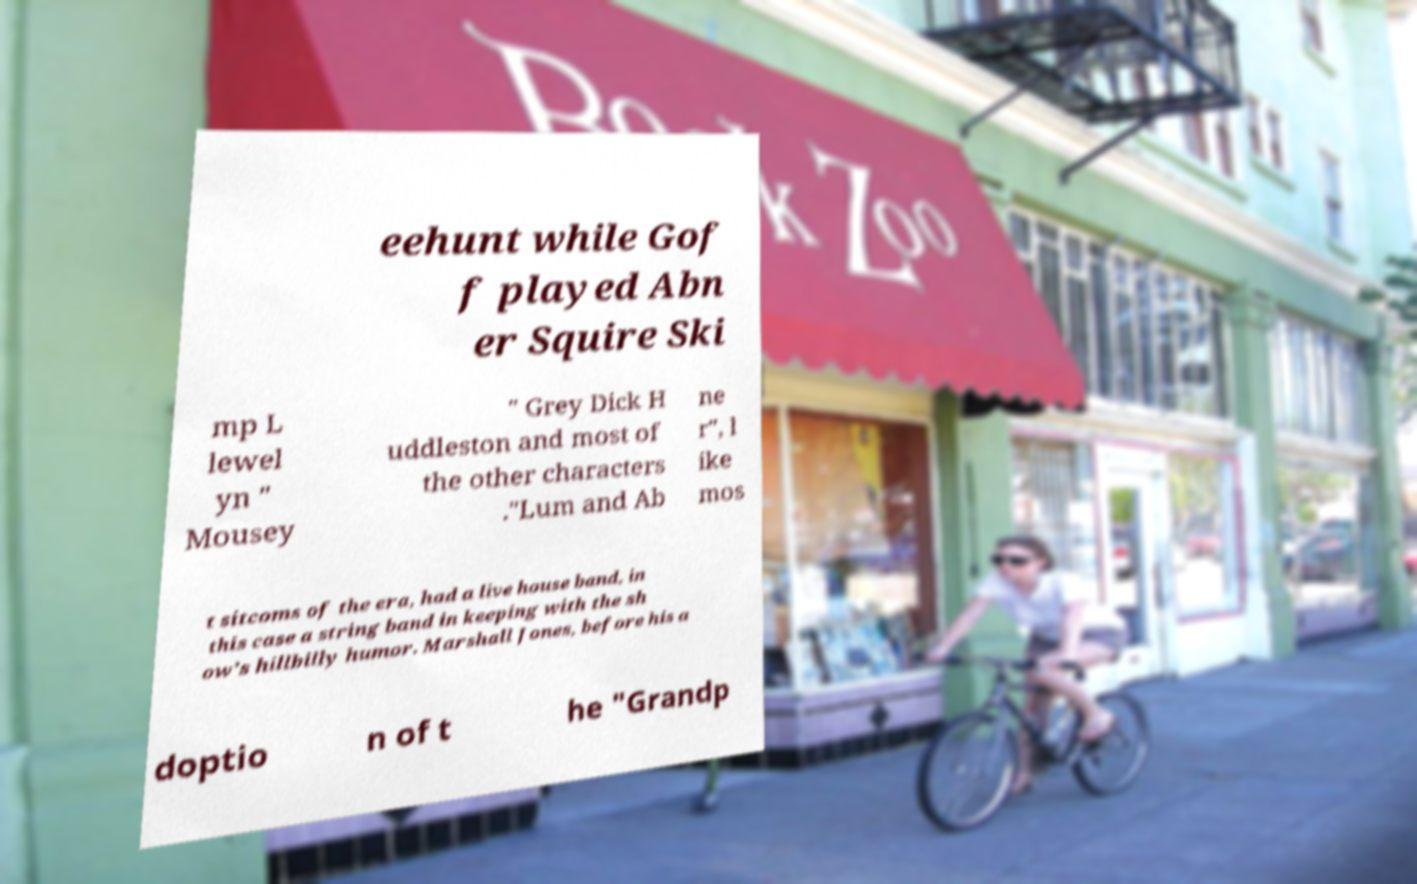Please identify and transcribe the text found in this image. eehunt while Gof f played Abn er Squire Ski mp L lewel yn " Mousey " Grey Dick H uddleston and most of the other characters ."Lum and Ab ne r", l ike mos t sitcoms of the era, had a live house band, in this case a string band in keeping with the sh ow's hillbilly humor. Marshall Jones, before his a doptio n of t he "Grandp 